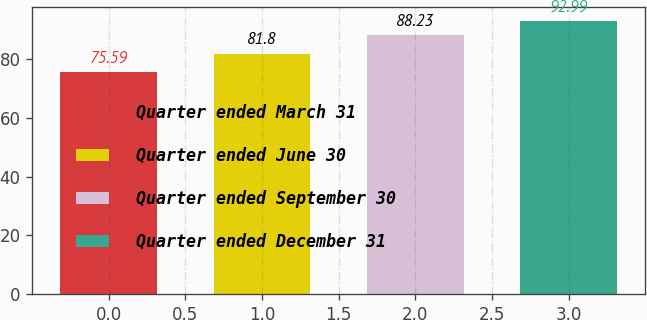Convert chart. <chart><loc_0><loc_0><loc_500><loc_500><bar_chart><fcel>Quarter ended March 31<fcel>Quarter ended June 30<fcel>Quarter ended September 30<fcel>Quarter ended December 31<nl><fcel>75.59<fcel>81.8<fcel>88.23<fcel>92.99<nl></chart> 